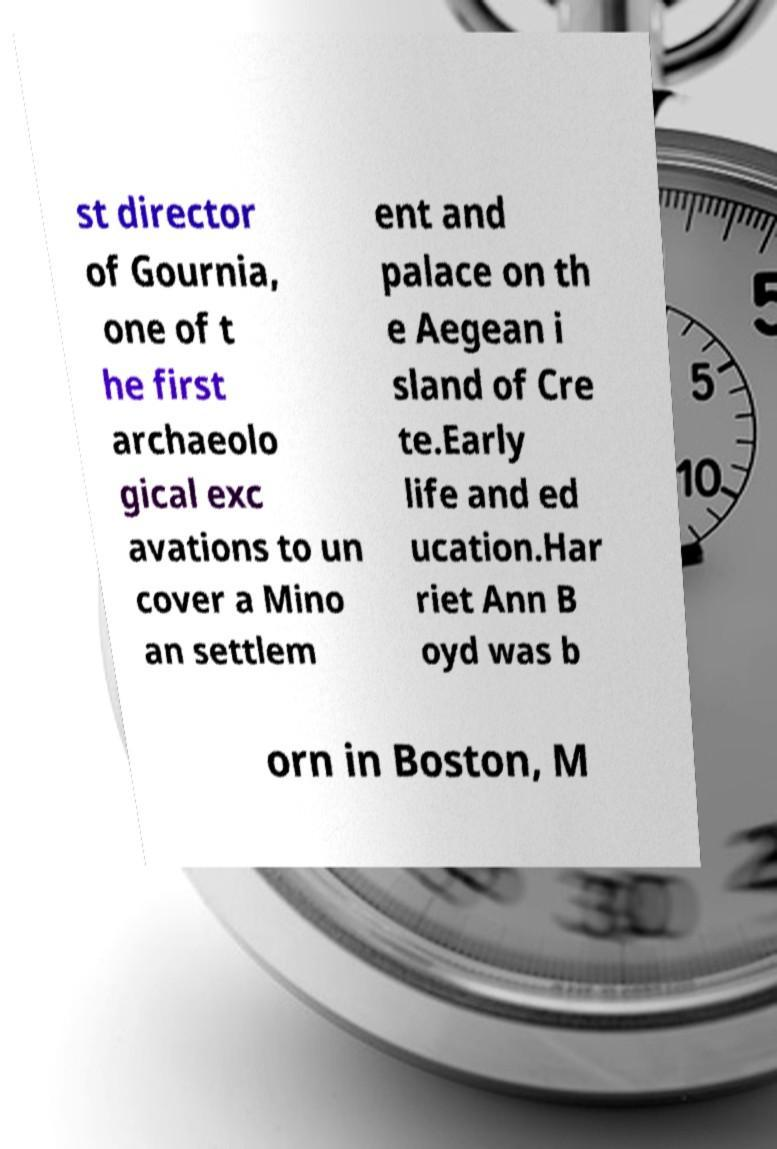Can you accurately transcribe the text from the provided image for me? st director of Gournia, one of t he first archaeolo gical exc avations to un cover a Mino an settlem ent and palace on th e Aegean i sland of Cre te.Early life and ed ucation.Har riet Ann B oyd was b orn in Boston, M 